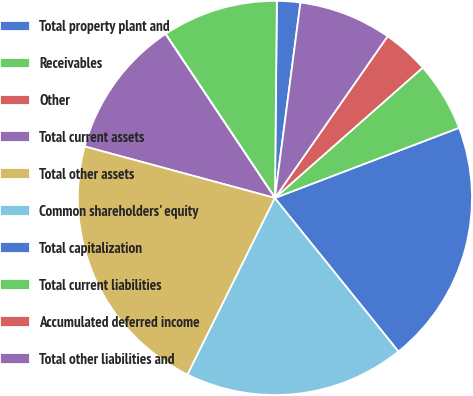Convert chart to OTSL. <chart><loc_0><loc_0><loc_500><loc_500><pie_chart><fcel>Total property plant and<fcel>Receivables<fcel>Other<fcel>Total current assets<fcel>Total other assets<fcel>Common shareholders' equity<fcel>Total capitalization<fcel>Total current liabilities<fcel>Accumulated deferred income<fcel>Total other liabilities and<nl><fcel>1.91%<fcel>9.52%<fcel>0.01%<fcel>11.42%<fcel>21.9%<fcel>18.1%<fcel>20.0%<fcel>5.71%<fcel>3.81%<fcel>7.62%<nl></chart> 